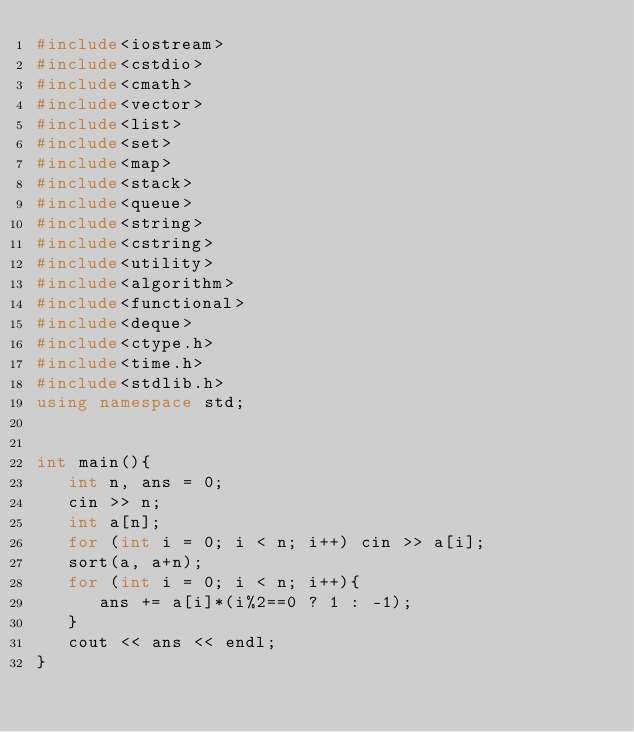Convert code to text. <code><loc_0><loc_0><loc_500><loc_500><_C++_>#include<iostream>
#include<cstdio>
#include<cmath>
#include<vector>
#include<list>
#include<set>
#include<map>
#include<stack>
#include<queue>
#include<string>
#include<cstring>
#include<utility>
#include<algorithm>
#include<functional>
#include<deque>
#include<ctype.h>
#include<time.h>
#include<stdlib.h>
using namespace std;


int main(){
   int n, ans = 0;
   cin >> n;
   int a[n];
   for (int i = 0; i < n; i++) cin >> a[i];
   sort(a, a+n);
   for (int i = 0; i < n; i++){
      ans += a[i]*(i%2==0 ? 1 : -1);
   }
   cout << ans << endl;
}
</code> 